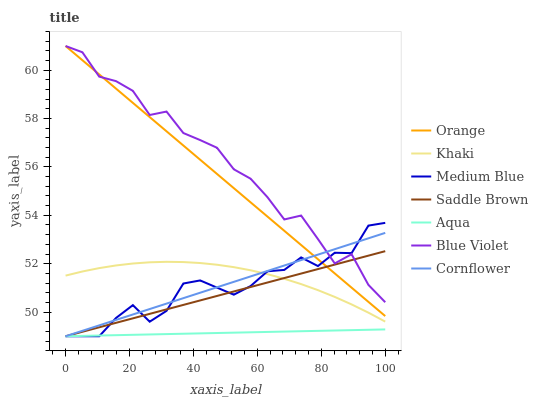Does Aqua have the minimum area under the curve?
Answer yes or no. Yes. Does Blue Violet have the maximum area under the curve?
Answer yes or no. Yes. Does Khaki have the minimum area under the curve?
Answer yes or no. No. Does Khaki have the maximum area under the curve?
Answer yes or no. No. Is Saddle Brown the smoothest?
Answer yes or no. Yes. Is Blue Violet the roughest?
Answer yes or no. Yes. Is Khaki the smoothest?
Answer yes or no. No. Is Khaki the roughest?
Answer yes or no. No. Does Cornflower have the lowest value?
Answer yes or no. Yes. Does Khaki have the lowest value?
Answer yes or no. No. Does Blue Violet have the highest value?
Answer yes or no. Yes. Does Khaki have the highest value?
Answer yes or no. No. Is Aqua less than Orange?
Answer yes or no. Yes. Is Orange greater than Aqua?
Answer yes or no. Yes. Does Saddle Brown intersect Cornflower?
Answer yes or no. Yes. Is Saddle Brown less than Cornflower?
Answer yes or no. No. Is Saddle Brown greater than Cornflower?
Answer yes or no. No. Does Aqua intersect Orange?
Answer yes or no. No. 